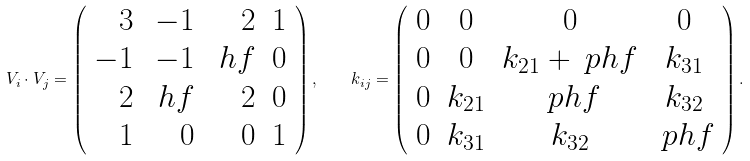<formula> <loc_0><loc_0><loc_500><loc_500>V _ { i } \cdot V _ { j } = \left ( \begin{array} { r r r r } 3 & - 1 & 2 & 1 \\ - 1 & - 1 & \ h f & 0 \\ 2 & \ h f & 2 & 0 \\ 1 & 0 & 0 & 1 \\ \end{array} \right ) , \quad k _ { i j } = \left ( \begin{array} { c c c c } 0 & 0 & 0 & 0 \\ 0 & 0 & k _ { 2 1 } + \ p h f & k _ { 3 1 } \\ 0 & k _ { 2 1 } & \ p h f & k _ { 3 2 } \\ 0 & k _ { 3 1 } & k _ { 3 2 } & \ p h f \\ \end{array} \right ) .</formula> 